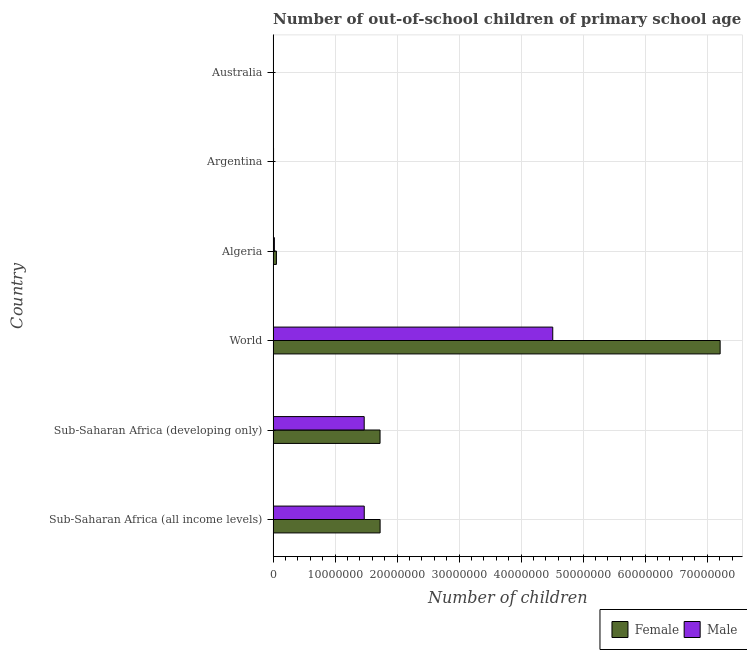Are the number of bars per tick equal to the number of legend labels?
Make the answer very short. Yes. Are the number of bars on each tick of the Y-axis equal?
Provide a short and direct response. Yes. How many bars are there on the 1st tick from the top?
Provide a succinct answer. 2. How many bars are there on the 4th tick from the bottom?
Keep it short and to the point. 2. What is the label of the 5th group of bars from the top?
Your response must be concise. Sub-Saharan Africa (developing only). In how many cases, is the number of bars for a given country not equal to the number of legend labels?
Offer a very short reply. 0. What is the number of male out-of-school students in Sub-Saharan Africa (all income levels)?
Your answer should be compact. 1.47e+07. Across all countries, what is the maximum number of male out-of-school students?
Keep it short and to the point. 4.51e+07. Across all countries, what is the minimum number of female out-of-school students?
Offer a very short reply. 2.26e+04. What is the total number of female out-of-school students in the graph?
Provide a succinct answer. 1.07e+08. What is the difference between the number of male out-of-school students in Algeria and that in World?
Your answer should be very brief. -4.49e+07. What is the difference between the number of female out-of-school students in Argentina and the number of male out-of-school students in World?
Ensure brevity in your answer.  -4.50e+07. What is the average number of male out-of-school students per country?
Ensure brevity in your answer.  1.25e+07. What is the difference between the number of male out-of-school students and number of female out-of-school students in Australia?
Offer a very short reply. 4632. In how many countries, is the number of female out-of-school students greater than 24000000 ?
Offer a terse response. 1. What is the ratio of the number of male out-of-school students in Algeria to that in Australia?
Make the answer very short. 7.42. Is the number of male out-of-school students in Algeria less than that in Australia?
Your answer should be compact. No. Is the difference between the number of female out-of-school students in Argentina and Sub-Saharan Africa (developing only) greater than the difference between the number of male out-of-school students in Argentina and Sub-Saharan Africa (developing only)?
Offer a terse response. No. What is the difference between the highest and the second highest number of female out-of-school students?
Your response must be concise. 5.48e+07. What is the difference between the highest and the lowest number of male out-of-school students?
Provide a short and direct response. 4.51e+07. In how many countries, is the number of female out-of-school students greater than the average number of female out-of-school students taken over all countries?
Your answer should be compact. 1. How many countries are there in the graph?
Give a very brief answer. 6. Are the values on the major ticks of X-axis written in scientific E-notation?
Offer a very short reply. No. How many legend labels are there?
Your response must be concise. 2. How are the legend labels stacked?
Your response must be concise. Horizontal. What is the title of the graph?
Offer a very short reply. Number of out-of-school children of primary school age of both genders in different countries. Does "Rural" appear as one of the legend labels in the graph?
Keep it short and to the point. No. What is the label or title of the X-axis?
Give a very brief answer. Number of children. What is the label or title of the Y-axis?
Give a very brief answer. Country. What is the Number of children of Female in Sub-Saharan Africa (all income levels)?
Give a very brief answer. 1.73e+07. What is the Number of children of Male in Sub-Saharan Africa (all income levels)?
Ensure brevity in your answer.  1.47e+07. What is the Number of children of Female in Sub-Saharan Africa (developing only)?
Offer a very short reply. 1.72e+07. What is the Number of children in Male in Sub-Saharan Africa (developing only)?
Provide a succinct answer. 1.47e+07. What is the Number of children of Female in World?
Provide a short and direct response. 7.21e+07. What is the Number of children of Male in World?
Make the answer very short. 4.51e+07. What is the Number of children in Female in Algeria?
Offer a terse response. 5.33e+05. What is the Number of children in Male in Algeria?
Offer a terse response. 2.02e+05. What is the Number of children in Female in Argentina?
Keep it short and to the point. 5.46e+04. What is the Number of children in Male in Argentina?
Provide a succinct answer. 6.96e+04. What is the Number of children in Female in Australia?
Offer a very short reply. 2.26e+04. What is the Number of children in Male in Australia?
Make the answer very short. 2.72e+04. Across all countries, what is the maximum Number of children in Female?
Make the answer very short. 7.21e+07. Across all countries, what is the maximum Number of children of Male?
Give a very brief answer. 4.51e+07. Across all countries, what is the minimum Number of children of Female?
Provide a short and direct response. 2.26e+04. Across all countries, what is the minimum Number of children of Male?
Keep it short and to the point. 2.72e+04. What is the total Number of children in Female in the graph?
Make the answer very short. 1.07e+08. What is the total Number of children in Male in the graph?
Provide a succinct answer. 7.48e+07. What is the difference between the Number of children in Female in Sub-Saharan Africa (all income levels) and that in Sub-Saharan Africa (developing only)?
Offer a very short reply. 8856. What is the difference between the Number of children of Male in Sub-Saharan Africa (all income levels) and that in Sub-Saharan Africa (developing only)?
Your answer should be very brief. 8156. What is the difference between the Number of children in Female in Sub-Saharan Africa (all income levels) and that in World?
Keep it short and to the point. -5.48e+07. What is the difference between the Number of children of Male in Sub-Saharan Africa (all income levels) and that in World?
Offer a very short reply. -3.04e+07. What is the difference between the Number of children of Female in Sub-Saharan Africa (all income levels) and that in Algeria?
Keep it short and to the point. 1.67e+07. What is the difference between the Number of children in Male in Sub-Saharan Africa (all income levels) and that in Algeria?
Your answer should be compact. 1.45e+07. What is the difference between the Number of children in Female in Sub-Saharan Africa (all income levels) and that in Argentina?
Offer a very short reply. 1.72e+07. What is the difference between the Number of children of Male in Sub-Saharan Africa (all income levels) and that in Argentina?
Your response must be concise. 1.46e+07. What is the difference between the Number of children in Female in Sub-Saharan Africa (all income levels) and that in Australia?
Make the answer very short. 1.72e+07. What is the difference between the Number of children in Male in Sub-Saharan Africa (all income levels) and that in Australia?
Make the answer very short. 1.47e+07. What is the difference between the Number of children of Female in Sub-Saharan Africa (developing only) and that in World?
Make the answer very short. -5.48e+07. What is the difference between the Number of children of Male in Sub-Saharan Africa (developing only) and that in World?
Your answer should be very brief. -3.04e+07. What is the difference between the Number of children of Female in Sub-Saharan Africa (developing only) and that in Algeria?
Your response must be concise. 1.67e+07. What is the difference between the Number of children in Male in Sub-Saharan Africa (developing only) and that in Algeria?
Give a very brief answer. 1.45e+07. What is the difference between the Number of children in Female in Sub-Saharan Africa (developing only) and that in Argentina?
Your answer should be compact. 1.72e+07. What is the difference between the Number of children in Male in Sub-Saharan Africa (developing only) and that in Argentina?
Provide a succinct answer. 1.46e+07. What is the difference between the Number of children of Female in Sub-Saharan Africa (developing only) and that in Australia?
Your answer should be very brief. 1.72e+07. What is the difference between the Number of children in Male in Sub-Saharan Africa (developing only) and that in Australia?
Your response must be concise. 1.47e+07. What is the difference between the Number of children in Female in World and that in Algeria?
Keep it short and to the point. 7.16e+07. What is the difference between the Number of children in Male in World and that in Algeria?
Offer a terse response. 4.49e+07. What is the difference between the Number of children of Female in World and that in Argentina?
Ensure brevity in your answer.  7.20e+07. What is the difference between the Number of children in Male in World and that in Argentina?
Your answer should be very brief. 4.50e+07. What is the difference between the Number of children of Female in World and that in Australia?
Ensure brevity in your answer.  7.21e+07. What is the difference between the Number of children in Male in World and that in Australia?
Give a very brief answer. 4.51e+07. What is the difference between the Number of children in Female in Algeria and that in Argentina?
Offer a very short reply. 4.79e+05. What is the difference between the Number of children in Male in Algeria and that in Argentina?
Make the answer very short. 1.32e+05. What is the difference between the Number of children in Female in Algeria and that in Australia?
Your answer should be very brief. 5.11e+05. What is the difference between the Number of children of Male in Algeria and that in Australia?
Make the answer very short. 1.75e+05. What is the difference between the Number of children of Female in Argentina and that in Australia?
Offer a terse response. 3.20e+04. What is the difference between the Number of children in Male in Argentina and that in Australia?
Your answer should be compact. 4.24e+04. What is the difference between the Number of children in Female in Sub-Saharan Africa (all income levels) and the Number of children in Male in Sub-Saharan Africa (developing only)?
Give a very brief answer. 2.57e+06. What is the difference between the Number of children in Female in Sub-Saharan Africa (all income levels) and the Number of children in Male in World?
Your answer should be very brief. -2.78e+07. What is the difference between the Number of children in Female in Sub-Saharan Africa (all income levels) and the Number of children in Male in Algeria?
Make the answer very short. 1.71e+07. What is the difference between the Number of children of Female in Sub-Saharan Africa (all income levels) and the Number of children of Male in Argentina?
Offer a very short reply. 1.72e+07. What is the difference between the Number of children in Female in Sub-Saharan Africa (all income levels) and the Number of children in Male in Australia?
Your answer should be very brief. 1.72e+07. What is the difference between the Number of children in Female in Sub-Saharan Africa (developing only) and the Number of children in Male in World?
Keep it short and to the point. -2.79e+07. What is the difference between the Number of children in Female in Sub-Saharan Africa (developing only) and the Number of children in Male in Algeria?
Your answer should be compact. 1.70e+07. What is the difference between the Number of children in Female in Sub-Saharan Africa (developing only) and the Number of children in Male in Argentina?
Your answer should be very brief. 1.72e+07. What is the difference between the Number of children in Female in Sub-Saharan Africa (developing only) and the Number of children in Male in Australia?
Provide a short and direct response. 1.72e+07. What is the difference between the Number of children in Female in World and the Number of children in Male in Algeria?
Your response must be concise. 7.19e+07. What is the difference between the Number of children of Female in World and the Number of children of Male in Argentina?
Keep it short and to the point. 7.20e+07. What is the difference between the Number of children of Female in World and the Number of children of Male in Australia?
Make the answer very short. 7.21e+07. What is the difference between the Number of children of Female in Algeria and the Number of children of Male in Argentina?
Your response must be concise. 4.64e+05. What is the difference between the Number of children of Female in Algeria and the Number of children of Male in Australia?
Keep it short and to the point. 5.06e+05. What is the difference between the Number of children of Female in Argentina and the Number of children of Male in Australia?
Keep it short and to the point. 2.74e+04. What is the average Number of children in Female per country?
Provide a succinct answer. 1.79e+07. What is the average Number of children in Male per country?
Your answer should be compact. 1.25e+07. What is the difference between the Number of children of Female and Number of children of Male in Sub-Saharan Africa (all income levels)?
Keep it short and to the point. 2.56e+06. What is the difference between the Number of children in Female and Number of children in Male in Sub-Saharan Africa (developing only)?
Provide a succinct answer. 2.56e+06. What is the difference between the Number of children in Female and Number of children in Male in World?
Give a very brief answer. 2.70e+07. What is the difference between the Number of children in Female and Number of children in Male in Algeria?
Keep it short and to the point. 3.31e+05. What is the difference between the Number of children of Female and Number of children of Male in Argentina?
Offer a terse response. -1.50e+04. What is the difference between the Number of children of Female and Number of children of Male in Australia?
Offer a very short reply. -4632. What is the ratio of the Number of children of Female in Sub-Saharan Africa (all income levels) to that in Sub-Saharan Africa (developing only)?
Ensure brevity in your answer.  1. What is the ratio of the Number of children in Male in Sub-Saharan Africa (all income levels) to that in Sub-Saharan Africa (developing only)?
Make the answer very short. 1. What is the ratio of the Number of children of Female in Sub-Saharan Africa (all income levels) to that in World?
Give a very brief answer. 0.24. What is the ratio of the Number of children in Male in Sub-Saharan Africa (all income levels) to that in World?
Your answer should be compact. 0.33. What is the ratio of the Number of children of Female in Sub-Saharan Africa (all income levels) to that in Algeria?
Give a very brief answer. 32.35. What is the ratio of the Number of children in Male in Sub-Saharan Africa (all income levels) to that in Algeria?
Provide a succinct answer. 72.72. What is the ratio of the Number of children in Female in Sub-Saharan Africa (all income levels) to that in Argentina?
Your answer should be very brief. 315.75. What is the ratio of the Number of children in Male in Sub-Saharan Africa (all income levels) to that in Argentina?
Keep it short and to the point. 211.13. What is the ratio of the Number of children in Female in Sub-Saharan Africa (all income levels) to that in Australia?
Your answer should be very brief. 763.14. What is the ratio of the Number of children of Male in Sub-Saharan Africa (all income levels) to that in Australia?
Offer a very short reply. 539.48. What is the ratio of the Number of children in Female in Sub-Saharan Africa (developing only) to that in World?
Your answer should be very brief. 0.24. What is the ratio of the Number of children in Male in Sub-Saharan Africa (developing only) to that in World?
Your answer should be very brief. 0.33. What is the ratio of the Number of children of Female in Sub-Saharan Africa (developing only) to that in Algeria?
Give a very brief answer. 32.33. What is the ratio of the Number of children of Male in Sub-Saharan Africa (developing only) to that in Algeria?
Offer a terse response. 72.67. What is the ratio of the Number of children of Female in Sub-Saharan Africa (developing only) to that in Argentina?
Your answer should be very brief. 315.59. What is the ratio of the Number of children of Male in Sub-Saharan Africa (developing only) to that in Argentina?
Give a very brief answer. 211.01. What is the ratio of the Number of children of Female in Sub-Saharan Africa (developing only) to that in Australia?
Keep it short and to the point. 762.74. What is the ratio of the Number of children in Male in Sub-Saharan Africa (developing only) to that in Australia?
Ensure brevity in your answer.  539.19. What is the ratio of the Number of children in Female in World to that in Algeria?
Provide a succinct answer. 135.17. What is the ratio of the Number of children of Male in World to that in Algeria?
Your response must be concise. 223.14. What is the ratio of the Number of children in Female in World to that in Argentina?
Offer a terse response. 1319.31. What is the ratio of the Number of children in Male in World to that in Argentina?
Your response must be concise. 647.88. What is the ratio of the Number of children of Female in World to that in Australia?
Offer a very short reply. 3188.63. What is the ratio of the Number of children of Male in World to that in Australia?
Provide a succinct answer. 1655.47. What is the ratio of the Number of children in Female in Algeria to that in Argentina?
Provide a short and direct response. 9.76. What is the ratio of the Number of children in Male in Algeria to that in Argentina?
Keep it short and to the point. 2.9. What is the ratio of the Number of children of Female in Algeria to that in Australia?
Keep it short and to the point. 23.59. What is the ratio of the Number of children in Male in Algeria to that in Australia?
Your answer should be very brief. 7.42. What is the ratio of the Number of children of Female in Argentina to that in Australia?
Your answer should be compact. 2.42. What is the ratio of the Number of children of Male in Argentina to that in Australia?
Your response must be concise. 2.56. What is the difference between the highest and the second highest Number of children of Female?
Ensure brevity in your answer.  5.48e+07. What is the difference between the highest and the second highest Number of children of Male?
Your answer should be compact. 3.04e+07. What is the difference between the highest and the lowest Number of children of Female?
Your response must be concise. 7.21e+07. What is the difference between the highest and the lowest Number of children in Male?
Make the answer very short. 4.51e+07. 